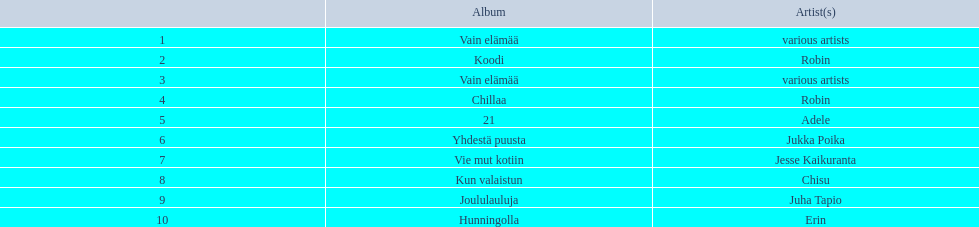Who is the artist for 21 album? Adele. Who is the artist for kun valaistun? Chisu. Which album had the same artist as chillaa? Koodi. 